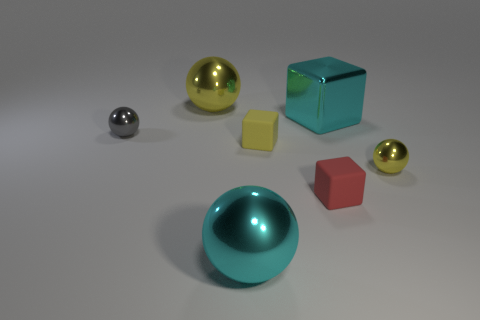Subtract all cyan metal blocks. How many blocks are left? 2 Add 1 tiny yellow rubber things. How many objects exist? 8 Subtract all brown cylinders. How many yellow balls are left? 2 Subtract all yellow spheres. How many spheres are left? 2 Subtract all spheres. How many objects are left? 3 Add 6 tiny yellow metallic things. How many tiny yellow metallic things are left? 7 Add 3 metal objects. How many metal objects exist? 8 Subtract 1 cyan balls. How many objects are left? 6 Subtract all cyan spheres. Subtract all yellow blocks. How many spheres are left? 3 Subtract all purple balls. Subtract all yellow metal objects. How many objects are left? 5 